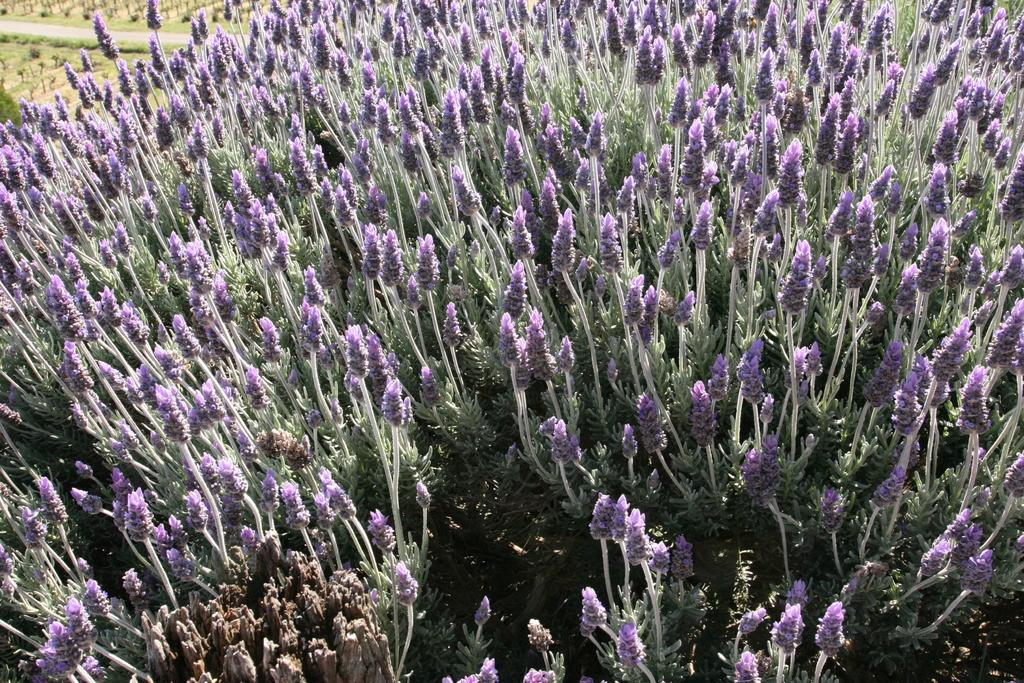What is the dominant color of the flowers in the image? The field of flowers in the image is purple. What type of flowers are depicted in the image? The facts provided do not specify the type of flowers, only their color. Can you describe the landscape in the image? The image features a field of purple flowers. What is the taste of the theory mentioned in the image? There is no mention of a theory in the image, and therefore no taste can be associated with it. 